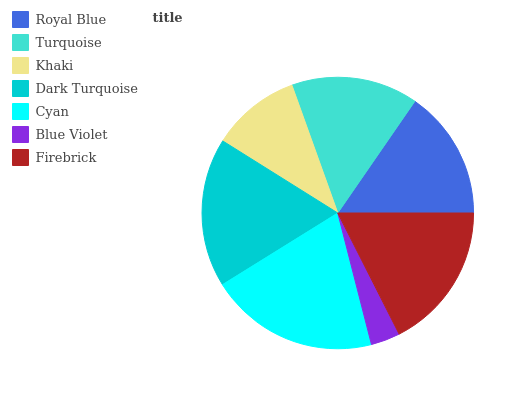Is Blue Violet the minimum?
Answer yes or no. Yes. Is Cyan the maximum?
Answer yes or no. Yes. Is Turquoise the minimum?
Answer yes or no. No. Is Turquoise the maximum?
Answer yes or no. No. Is Royal Blue greater than Turquoise?
Answer yes or no. Yes. Is Turquoise less than Royal Blue?
Answer yes or no. Yes. Is Turquoise greater than Royal Blue?
Answer yes or no. No. Is Royal Blue less than Turquoise?
Answer yes or no. No. Is Royal Blue the high median?
Answer yes or no. Yes. Is Royal Blue the low median?
Answer yes or no. Yes. Is Blue Violet the high median?
Answer yes or no. No. Is Firebrick the low median?
Answer yes or no. No. 